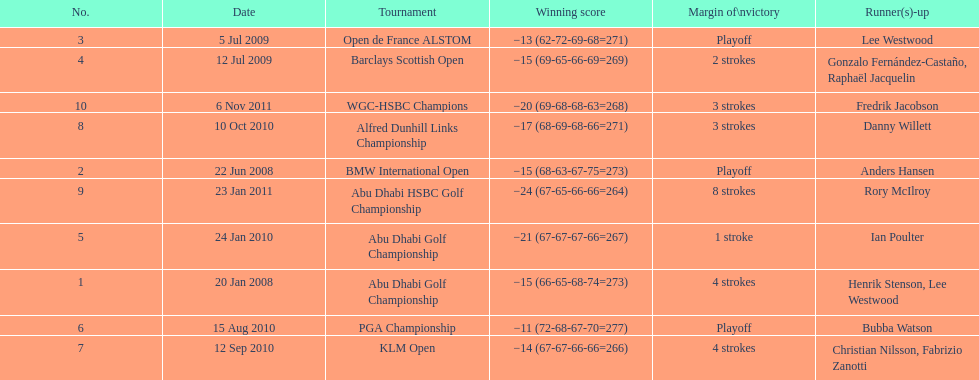How long separated the playoff victory at bmw international open and the 4 stroke victory at the klm open? 2 years. 